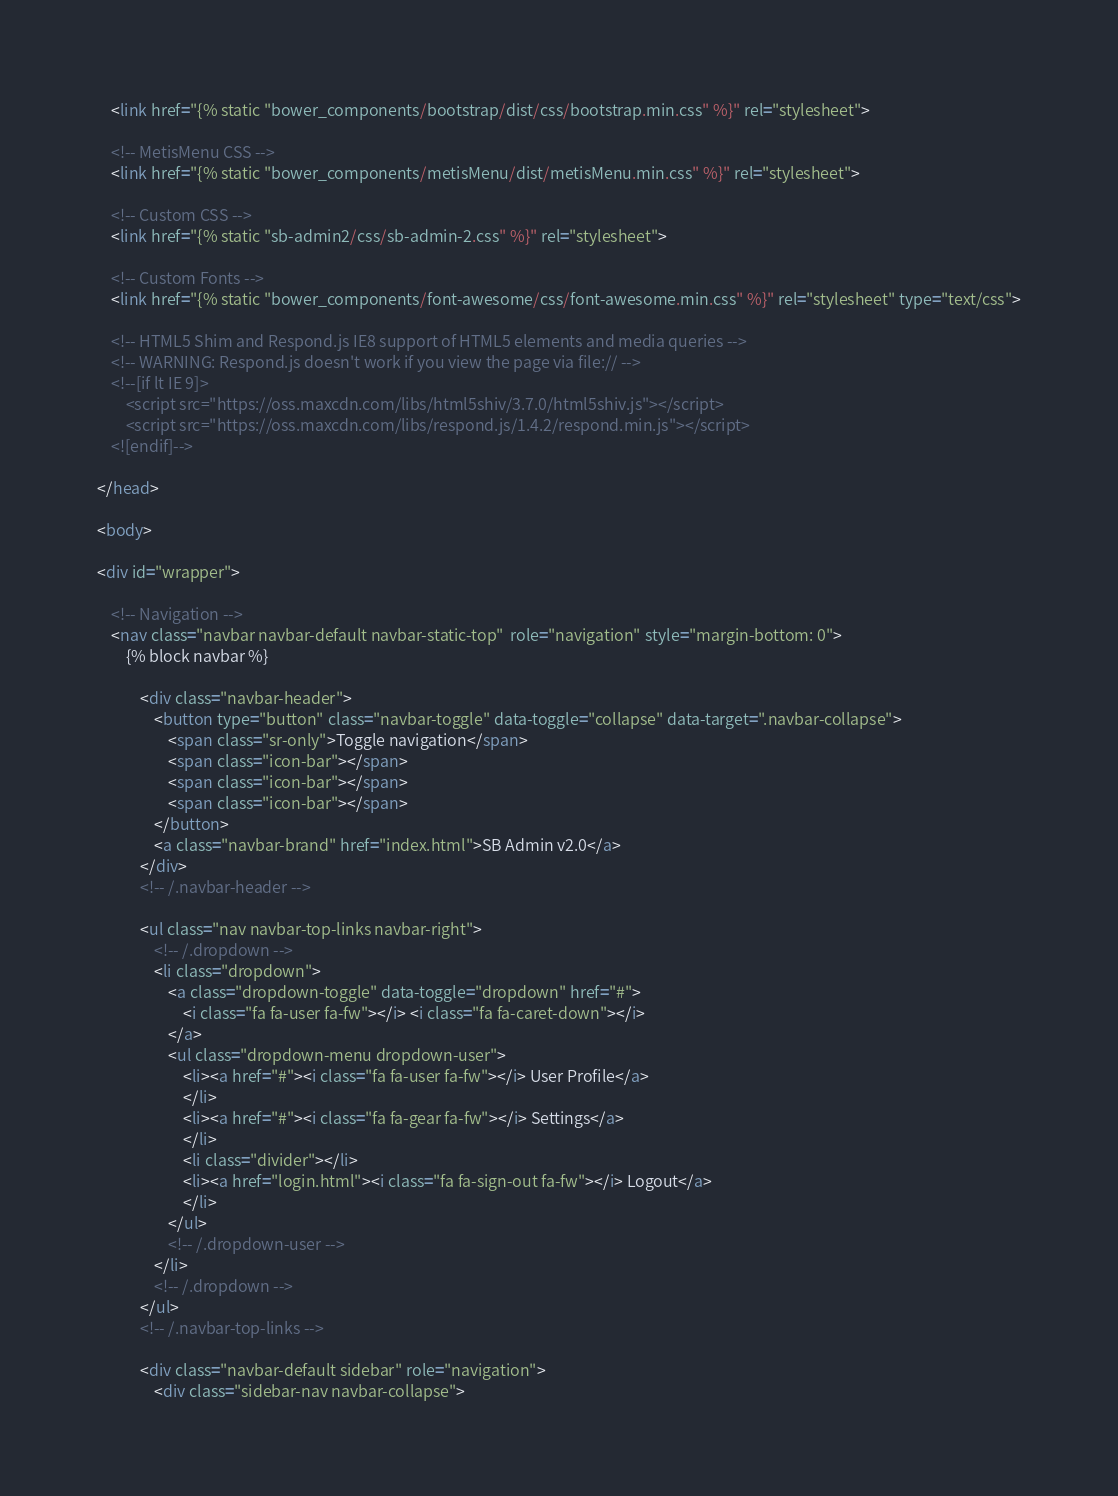Convert code to text. <code><loc_0><loc_0><loc_500><loc_500><_HTML_>    <link href="{% static "bower_components/bootstrap/dist/css/bootstrap.min.css" %}" rel="stylesheet">

    <!-- MetisMenu CSS -->
    <link href="{% static "bower_components/metisMenu/dist/metisMenu.min.css" %}" rel="stylesheet">

    <!-- Custom CSS -->
    <link href="{% static "sb-admin2/css/sb-admin-2.css" %}" rel="stylesheet">

    <!-- Custom Fonts -->
    <link href="{% static "bower_components/font-awesome/css/font-awesome.min.css" %}" rel="stylesheet" type="text/css">

    <!-- HTML5 Shim and Respond.js IE8 support of HTML5 elements and media queries -->
    <!-- WARNING: Respond.js doesn't work if you view the page via file:// -->
    <!--[if lt IE 9]>
        <script src="https://oss.maxcdn.com/libs/html5shiv/3.7.0/html5shiv.js"></script>
        <script src="https://oss.maxcdn.com/libs/respond.js/1.4.2/respond.min.js"></script>
    <![endif]-->

</head>

<body>

<div id="wrapper">

    <!-- Navigation -->
    <nav class="navbar navbar-default navbar-static-top"  role="navigation" style="margin-bottom: 0">
        {% block navbar %}

            <div class="navbar-header">
                <button type="button" class="navbar-toggle" data-toggle="collapse" data-target=".navbar-collapse">
                    <span class="sr-only">Toggle navigation</span>
                    <span class="icon-bar"></span>
                    <span class="icon-bar"></span>
                    <span class="icon-bar"></span>
                </button>
                <a class="navbar-brand" href="index.html">SB Admin v2.0</a>
            </div>
            <!-- /.navbar-header -->

            <ul class="nav navbar-top-links navbar-right">
                <!-- /.dropdown -->
                <li class="dropdown">
                    <a class="dropdown-toggle" data-toggle="dropdown" href="#">
                        <i class="fa fa-user fa-fw"></i> <i class="fa fa-caret-down"></i>
                    </a>
                    <ul class="dropdown-menu dropdown-user">
                        <li><a href="#"><i class="fa fa-user fa-fw"></i> User Profile</a>
                        </li>
                        <li><a href="#"><i class="fa fa-gear fa-fw"></i> Settings</a>
                        </li>
                        <li class="divider"></li>
                        <li><a href="login.html"><i class="fa fa-sign-out fa-fw"></i> Logout</a>
                        </li>
                    </ul>
                    <!-- /.dropdown-user -->
                </li>
                <!-- /.dropdown -->
            </ul>
            <!-- /.navbar-top-links -->

            <div class="navbar-default sidebar" role="navigation">
                <div class="sidebar-nav navbar-collapse"></code> 